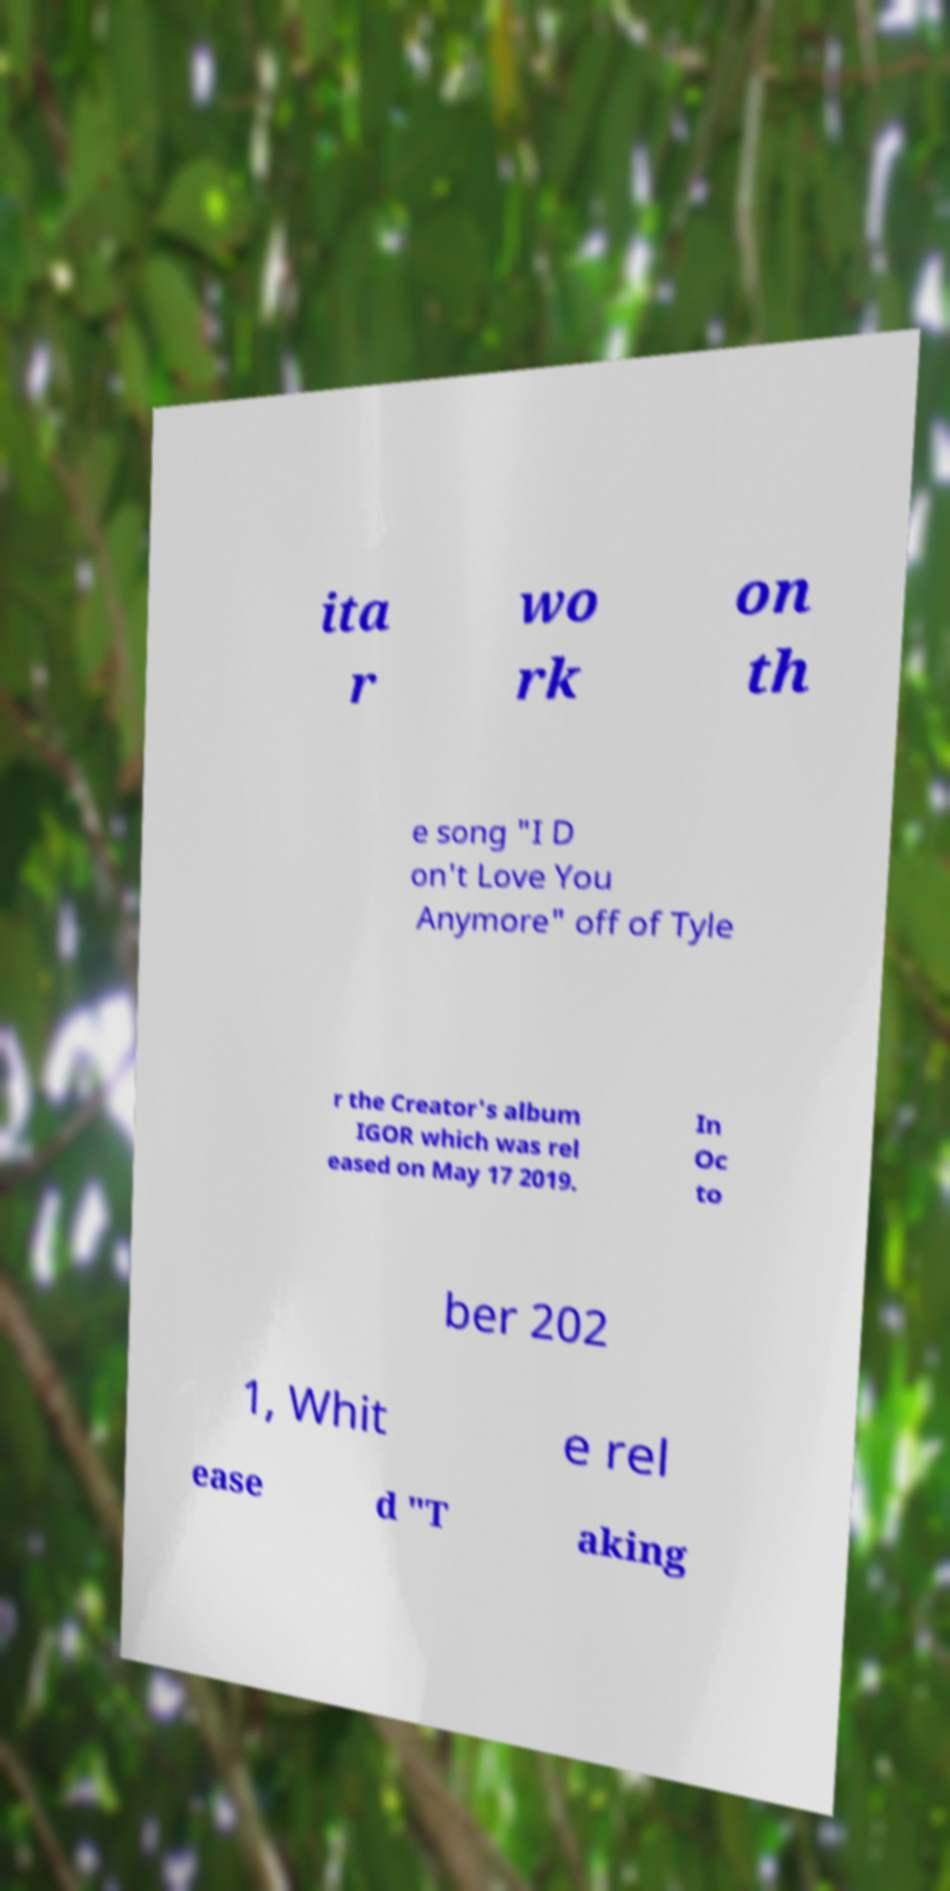For documentation purposes, I need the text within this image transcribed. Could you provide that? ita r wo rk on th e song "I D on't Love You Anymore" off of Tyle r the Creator's album IGOR which was rel eased on May 17 2019. In Oc to ber 202 1, Whit e rel ease d "T aking 